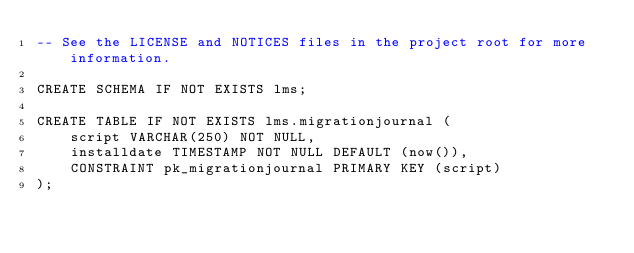<code> <loc_0><loc_0><loc_500><loc_500><_SQL_>-- See the LICENSE and NOTICES files in the project root for more information.

CREATE SCHEMA IF NOT EXISTS lms;

CREATE TABLE IF NOT EXISTS lms.migrationjournal (
    script VARCHAR(250) NOT NULL,
    installdate TIMESTAMP NOT NULL DEFAULT (now()),
    CONSTRAINT pk_migrationjournal PRIMARY KEY (script)
);
</code> 